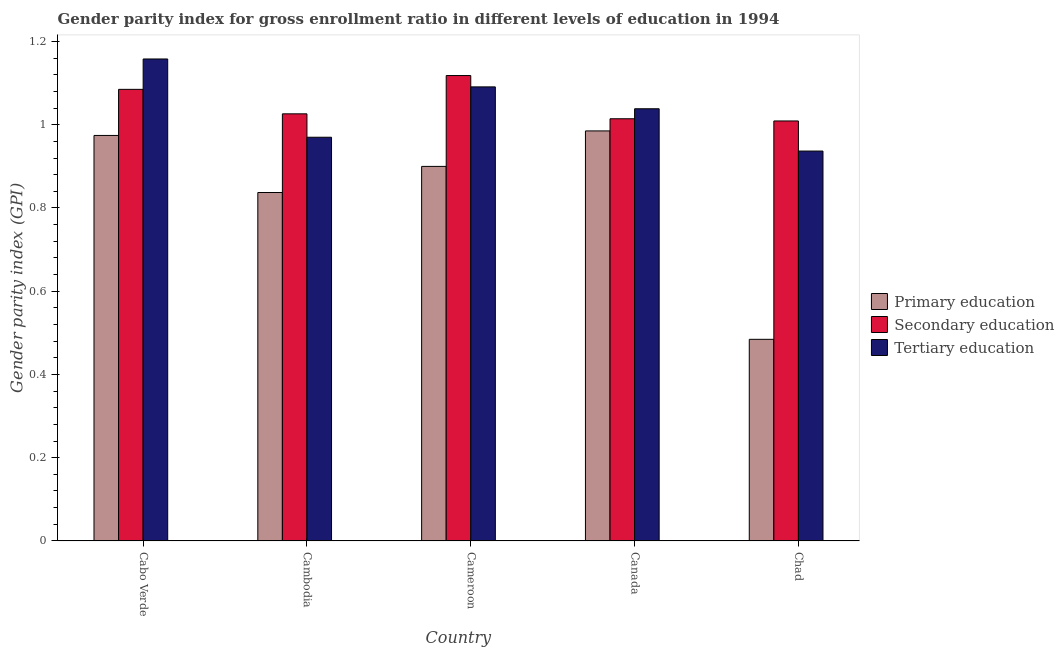How many bars are there on the 4th tick from the left?
Your answer should be compact. 3. How many bars are there on the 5th tick from the right?
Offer a very short reply. 3. What is the label of the 1st group of bars from the left?
Your answer should be compact. Cabo Verde. In how many cases, is the number of bars for a given country not equal to the number of legend labels?
Provide a succinct answer. 0. What is the gender parity index in primary education in Cameroon?
Your response must be concise. 0.9. Across all countries, what is the maximum gender parity index in secondary education?
Your answer should be very brief. 1.12. Across all countries, what is the minimum gender parity index in primary education?
Offer a terse response. 0.48. In which country was the gender parity index in tertiary education maximum?
Offer a terse response. Cabo Verde. In which country was the gender parity index in secondary education minimum?
Provide a succinct answer. Chad. What is the total gender parity index in primary education in the graph?
Offer a very short reply. 4.18. What is the difference between the gender parity index in secondary education in Cabo Verde and that in Canada?
Provide a short and direct response. 0.07. What is the difference between the gender parity index in primary education in Cambodia and the gender parity index in tertiary education in Canada?
Your answer should be very brief. -0.2. What is the average gender parity index in secondary education per country?
Offer a very short reply. 1.05. What is the difference between the gender parity index in tertiary education and gender parity index in secondary education in Cabo Verde?
Make the answer very short. 0.07. What is the ratio of the gender parity index in tertiary education in Cambodia to that in Chad?
Give a very brief answer. 1.04. Is the gender parity index in primary education in Cameroon less than that in Canada?
Provide a short and direct response. Yes. What is the difference between the highest and the second highest gender parity index in tertiary education?
Make the answer very short. 0.07. What is the difference between the highest and the lowest gender parity index in secondary education?
Give a very brief answer. 0.11. What does the 2nd bar from the right in Canada represents?
Offer a terse response. Secondary education. Is it the case that in every country, the sum of the gender parity index in primary education and gender parity index in secondary education is greater than the gender parity index in tertiary education?
Offer a very short reply. Yes. Does the graph contain any zero values?
Provide a succinct answer. No. Does the graph contain grids?
Offer a very short reply. No. Where does the legend appear in the graph?
Your answer should be compact. Center right. How many legend labels are there?
Make the answer very short. 3. What is the title of the graph?
Your response must be concise. Gender parity index for gross enrollment ratio in different levels of education in 1994. What is the label or title of the Y-axis?
Provide a succinct answer. Gender parity index (GPI). What is the Gender parity index (GPI) of Primary education in Cabo Verde?
Provide a succinct answer. 0.97. What is the Gender parity index (GPI) of Secondary education in Cabo Verde?
Give a very brief answer. 1.09. What is the Gender parity index (GPI) in Tertiary education in Cabo Verde?
Give a very brief answer. 1.16. What is the Gender parity index (GPI) of Primary education in Cambodia?
Make the answer very short. 0.84. What is the Gender parity index (GPI) in Secondary education in Cambodia?
Ensure brevity in your answer.  1.03. What is the Gender parity index (GPI) of Tertiary education in Cambodia?
Your answer should be compact. 0.97. What is the Gender parity index (GPI) in Primary education in Cameroon?
Offer a very short reply. 0.9. What is the Gender parity index (GPI) of Secondary education in Cameroon?
Offer a terse response. 1.12. What is the Gender parity index (GPI) of Tertiary education in Cameroon?
Provide a short and direct response. 1.09. What is the Gender parity index (GPI) in Primary education in Canada?
Your answer should be compact. 0.99. What is the Gender parity index (GPI) of Secondary education in Canada?
Your response must be concise. 1.01. What is the Gender parity index (GPI) of Tertiary education in Canada?
Offer a very short reply. 1.04. What is the Gender parity index (GPI) in Primary education in Chad?
Provide a succinct answer. 0.48. What is the Gender parity index (GPI) of Secondary education in Chad?
Provide a short and direct response. 1.01. What is the Gender parity index (GPI) in Tertiary education in Chad?
Your response must be concise. 0.94. Across all countries, what is the maximum Gender parity index (GPI) in Primary education?
Your answer should be compact. 0.99. Across all countries, what is the maximum Gender parity index (GPI) in Secondary education?
Keep it short and to the point. 1.12. Across all countries, what is the maximum Gender parity index (GPI) in Tertiary education?
Your response must be concise. 1.16. Across all countries, what is the minimum Gender parity index (GPI) of Primary education?
Your response must be concise. 0.48. Across all countries, what is the minimum Gender parity index (GPI) in Secondary education?
Your answer should be compact. 1.01. Across all countries, what is the minimum Gender parity index (GPI) of Tertiary education?
Give a very brief answer. 0.94. What is the total Gender parity index (GPI) of Primary education in the graph?
Provide a succinct answer. 4.18. What is the total Gender parity index (GPI) in Secondary education in the graph?
Your response must be concise. 5.25. What is the total Gender parity index (GPI) of Tertiary education in the graph?
Your answer should be compact. 5.19. What is the difference between the Gender parity index (GPI) of Primary education in Cabo Verde and that in Cambodia?
Keep it short and to the point. 0.14. What is the difference between the Gender parity index (GPI) in Secondary education in Cabo Verde and that in Cambodia?
Provide a succinct answer. 0.06. What is the difference between the Gender parity index (GPI) in Tertiary education in Cabo Verde and that in Cambodia?
Your answer should be very brief. 0.19. What is the difference between the Gender parity index (GPI) in Primary education in Cabo Verde and that in Cameroon?
Give a very brief answer. 0.07. What is the difference between the Gender parity index (GPI) in Secondary education in Cabo Verde and that in Cameroon?
Offer a very short reply. -0.03. What is the difference between the Gender parity index (GPI) of Tertiary education in Cabo Verde and that in Cameroon?
Ensure brevity in your answer.  0.07. What is the difference between the Gender parity index (GPI) of Primary education in Cabo Verde and that in Canada?
Offer a very short reply. -0.01. What is the difference between the Gender parity index (GPI) of Secondary education in Cabo Verde and that in Canada?
Provide a succinct answer. 0.07. What is the difference between the Gender parity index (GPI) of Tertiary education in Cabo Verde and that in Canada?
Provide a short and direct response. 0.12. What is the difference between the Gender parity index (GPI) of Primary education in Cabo Verde and that in Chad?
Keep it short and to the point. 0.49. What is the difference between the Gender parity index (GPI) of Secondary education in Cabo Verde and that in Chad?
Give a very brief answer. 0.08. What is the difference between the Gender parity index (GPI) in Tertiary education in Cabo Verde and that in Chad?
Ensure brevity in your answer.  0.22. What is the difference between the Gender parity index (GPI) of Primary education in Cambodia and that in Cameroon?
Make the answer very short. -0.06. What is the difference between the Gender parity index (GPI) in Secondary education in Cambodia and that in Cameroon?
Offer a terse response. -0.09. What is the difference between the Gender parity index (GPI) in Tertiary education in Cambodia and that in Cameroon?
Make the answer very short. -0.12. What is the difference between the Gender parity index (GPI) of Primary education in Cambodia and that in Canada?
Provide a short and direct response. -0.15. What is the difference between the Gender parity index (GPI) of Secondary education in Cambodia and that in Canada?
Ensure brevity in your answer.  0.01. What is the difference between the Gender parity index (GPI) in Tertiary education in Cambodia and that in Canada?
Ensure brevity in your answer.  -0.07. What is the difference between the Gender parity index (GPI) of Primary education in Cambodia and that in Chad?
Make the answer very short. 0.35. What is the difference between the Gender parity index (GPI) of Secondary education in Cambodia and that in Chad?
Keep it short and to the point. 0.02. What is the difference between the Gender parity index (GPI) of Tertiary education in Cambodia and that in Chad?
Provide a succinct answer. 0.03. What is the difference between the Gender parity index (GPI) of Primary education in Cameroon and that in Canada?
Give a very brief answer. -0.09. What is the difference between the Gender parity index (GPI) of Secondary education in Cameroon and that in Canada?
Provide a short and direct response. 0.1. What is the difference between the Gender parity index (GPI) in Tertiary education in Cameroon and that in Canada?
Your answer should be compact. 0.05. What is the difference between the Gender parity index (GPI) in Primary education in Cameroon and that in Chad?
Offer a terse response. 0.42. What is the difference between the Gender parity index (GPI) in Secondary education in Cameroon and that in Chad?
Keep it short and to the point. 0.11. What is the difference between the Gender parity index (GPI) in Tertiary education in Cameroon and that in Chad?
Your response must be concise. 0.15. What is the difference between the Gender parity index (GPI) of Primary education in Canada and that in Chad?
Your answer should be very brief. 0.5. What is the difference between the Gender parity index (GPI) of Secondary education in Canada and that in Chad?
Give a very brief answer. 0.01. What is the difference between the Gender parity index (GPI) in Tertiary education in Canada and that in Chad?
Provide a short and direct response. 0.1. What is the difference between the Gender parity index (GPI) of Primary education in Cabo Verde and the Gender parity index (GPI) of Secondary education in Cambodia?
Offer a very short reply. -0.05. What is the difference between the Gender parity index (GPI) of Primary education in Cabo Verde and the Gender parity index (GPI) of Tertiary education in Cambodia?
Provide a short and direct response. 0. What is the difference between the Gender parity index (GPI) in Secondary education in Cabo Verde and the Gender parity index (GPI) in Tertiary education in Cambodia?
Your answer should be compact. 0.12. What is the difference between the Gender parity index (GPI) in Primary education in Cabo Verde and the Gender parity index (GPI) in Secondary education in Cameroon?
Your response must be concise. -0.14. What is the difference between the Gender parity index (GPI) of Primary education in Cabo Verde and the Gender parity index (GPI) of Tertiary education in Cameroon?
Provide a short and direct response. -0.12. What is the difference between the Gender parity index (GPI) in Secondary education in Cabo Verde and the Gender parity index (GPI) in Tertiary education in Cameroon?
Offer a terse response. -0.01. What is the difference between the Gender parity index (GPI) of Primary education in Cabo Verde and the Gender parity index (GPI) of Secondary education in Canada?
Offer a very short reply. -0.04. What is the difference between the Gender parity index (GPI) of Primary education in Cabo Verde and the Gender parity index (GPI) of Tertiary education in Canada?
Your answer should be compact. -0.06. What is the difference between the Gender parity index (GPI) of Secondary education in Cabo Verde and the Gender parity index (GPI) of Tertiary education in Canada?
Give a very brief answer. 0.05. What is the difference between the Gender parity index (GPI) in Primary education in Cabo Verde and the Gender parity index (GPI) in Secondary education in Chad?
Your response must be concise. -0.03. What is the difference between the Gender parity index (GPI) in Primary education in Cabo Verde and the Gender parity index (GPI) in Tertiary education in Chad?
Provide a succinct answer. 0.04. What is the difference between the Gender parity index (GPI) in Secondary education in Cabo Verde and the Gender parity index (GPI) in Tertiary education in Chad?
Offer a terse response. 0.15. What is the difference between the Gender parity index (GPI) in Primary education in Cambodia and the Gender parity index (GPI) in Secondary education in Cameroon?
Ensure brevity in your answer.  -0.28. What is the difference between the Gender parity index (GPI) in Primary education in Cambodia and the Gender parity index (GPI) in Tertiary education in Cameroon?
Make the answer very short. -0.25. What is the difference between the Gender parity index (GPI) in Secondary education in Cambodia and the Gender parity index (GPI) in Tertiary education in Cameroon?
Keep it short and to the point. -0.06. What is the difference between the Gender parity index (GPI) in Primary education in Cambodia and the Gender parity index (GPI) in Secondary education in Canada?
Your answer should be very brief. -0.18. What is the difference between the Gender parity index (GPI) of Primary education in Cambodia and the Gender parity index (GPI) of Tertiary education in Canada?
Offer a terse response. -0.2. What is the difference between the Gender parity index (GPI) of Secondary education in Cambodia and the Gender parity index (GPI) of Tertiary education in Canada?
Provide a short and direct response. -0.01. What is the difference between the Gender parity index (GPI) of Primary education in Cambodia and the Gender parity index (GPI) of Secondary education in Chad?
Your answer should be compact. -0.17. What is the difference between the Gender parity index (GPI) of Primary education in Cambodia and the Gender parity index (GPI) of Tertiary education in Chad?
Provide a short and direct response. -0.1. What is the difference between the Gender parity index (GPI) of Secondary education in Cambodia and the Gender parity index (GPI) of Tertiary education in Chad?
Provide a succinct answer. 0.09. What is the difference between the Gender parity index (GPI) of Primary education in Cameroon and the Gender parity index (GPI) of Secondary education in Canada?
Your answer should be very brief. -0.11. What is the difference between the Gender parity index (GPI) of Primary education in Cameroon and the Gender parity index (GPI) of Tertiary education in Canada?
Keep it short and to the point. -0.14. What is the difference between the Gender parity index (GPI) of Secondary education in Cameroon and the Gender parity index (GPI) of Tertiary education in Canada?
Your response must be concise. 0.08. What is the difference between the Gender parity index (GPI) of Primary education in Cameroon and the Gender parity index (GPI) of Secondary education in Chad?
Your answer should be very brief. -0.11. What is the difference between the Gender parity index (GPI) of Primary education in Cameroon and the Gender parity index (GPI) of Tertiary education in Chad?
Offer a terse response. -0.04. What is the difference between the Gender parity index (GPI) in Secondary education in Cameroon and the Gender parity index (GPI) in Tertiary education in Chad?
Keep it short and to the point. 0.18. What is the difference between the Gender parity index (GPI) in Primary education in Canada and the Gender parity index (GPI) in Secondary education in Chad?
Give a very brief answer. -0.02. What is the difference between the Gender parity index (GPI) in Primary education in Canada and the Gender parity index (GPI) in Tertiary education in Chad?
Your response must be concise. 0.05. What is the difference between the Gender parity index (GPI) of Secondary education in Canada and the Gender parity index (GPI) of Tertiary education in Chad?
Offer a very short reply. 0.08. What is the average Gender parity index (GPI) in Primary education per country?
Ensure brevity in your answer.  0.84. What is the average Gender parity index (GPI) of Secondary education per country?
Provide a short and direct response. 1.05. What is the average Gender parity index (GPI) in Tertiary education per country?
Ensure brevity in your answer.  1.04. What is the difference between the Gender parity index (GPI) in Primary education and Gender parity index (GPI) in Secondary education in Cabo Verde?
Provide a short and direct response. -0.11. What is the difference between the Gender parity index (GPI) in Primary education and Gender parity index (GPI) in Tertiary education in Cabo Verde?
Make the answer very short. -0.18. What is the difference between the Gender parity index (GPI) of Secondary education and Gender parity index (GPI) of Tertiary education in Cabo Verde?
Offer a terse response. -0.07. What is the difference between the Gender parity index (GPI) of Primary education and Gender parity index (GPI) of Secondary education in Cambodia?
Offer a very short reply. -0.19. What is the difference between the Gender parity index (GPI) of Primary education and Gender parity index (GPI) of Tertiary education in Cambodia?
Make the answer very short. -0.13. What is the difference between the Gender parity index (GPI) of Secondary education and Gender parity index (GPI) of Tertiary education in Cambodia?
Your answer should be very brief. 0.06. What is the difference between the Gender parity index (GPI) in Primary education and Gender parity index (GPI) in Secondary education in Cameroon?
Your answer should be very brief. -0.22. What is the difference between the Gender parity index (GPI) of Primary education and Gender parity index (GPI) of Tertiary education in Cameroon?
Offer a very short reply. -0.19. What is the difference between the Gender parity index (GPI) of Secondary education and Gender parity index (GPI) of Tertiary education in Cameroon?
Provide a succinct answer. 0.03. What is the difference between the Gender parity index (GPI) of Primary education and Gender parity index (GPI) of Secondary education in Canada?
Provide a short and direct response. -0.03. What is the difference between the Gender parity index (GPI) of Primary education and Gender parity index (GPI) of Tertiary education in Canada?
Provide a succinct answer. -0.05. What is the difference between the Gender parity index (GPI) of Secondary education and Gender parity index (GPI) of Tertiary education in Canada?
Provide a succinct answer. -0.02. What is the difference between the Gender parity index (GPI) in Primary education and Gender parity index (GPI) in Secondary education in Chad?
Provide a succinct answer. -0.52. What is the difference between the Gender parity index (GPI) of Primary education and Gender parity index (GPI) of Tertiary education in Chad?
Provide a short and direct response. -0.45. What is the difference between the Gender parity index (GPI) of Secondary education and Gender parity index (GPI) of Tertiary education in Chad?
Provide a short and direct response. 0.07. What is the ratio of the Gender parity index (GPI) in Primary education in Cabo Verde to that in Cambodia?
Your response must be concise. 1.16. What is the ratio of the Gender parity index (GPI) in Secondary education in Cabo Verde to that in Cambodia?
Offer a very short reply. 1.06. What is the ratio of the Gender parity index (GPI) in Tertiary education in Cabo Verde to that in Cambodia?
Your answer should be very brief. 1.19. What is the ratio of the Gender parity index (GPI) in Primary education in Cabo Verde to that in Cameroon?
Keep it short and to the point. 1.08. What is the ratio of the Gender parity index (GPI) of Secondary education in Cabo Verde to that in Cameroon?
Provide a succinct answer. 0.97. What is the ratio of the Gender parity index (GPI) of Tertiary education in Cabo Verde to that in Cameroon?
Offer a terse response. 1.06. What is the ratio of the Gender parity index (GPI) of Primary education in Cabo Verde to that in Canada?
Provide a succinct answer. 0.99. What is the ratio of the Gender parity index (GPI) in Secondary education in Cabo Verde to that in Canada?
Keep it short and to the point. 1.07. What is the ratio of the Gender parity index (GPI) in Tertiary education in Cabo Verde to that in Canada?
Ensure brevity in your answer.  1.12. What is the ratio of the Gender parity index (GPI) of Primary education in Cabo Verde to that in Chad?
Keep it short and to the point. 2.01. What is the ratio of the Gender parity index (GPI) in Secondary education in Cabo Verde to that in Chad?
Your answer should be very brief. 1.08. What is the ratio of the Gender parity index (GPI) in Tertiary education in Cabo Verde to that in Chad?
Your answer should be compact. 1.24. What is the ratio of the Gender parity index (GPI) in Primary education in Cambodia to that in Cameroon?
Offer a terse response. 0.93. What is the ratio of the Gender parity index (GPI) of Secondary education in Cambodia to that in Cameroon?
Your answer should be compact. 0.92. What is the ratio of the Gender parity index (GPI) in Tertiary education in Cambodia to that in Cameroon?
Your answer should be compact. 0.89. What is the ratio of the Gender parity index (GPI) in Primary education in Cambodia to that in Canada?
Provide a short and direct response. 0.85. What is the ratio of the Gender parity index (GPI) of Secondary education in Cambodia to that in Canada?
Offer a terse response. 1.01. What is the ratio of the Gender parity index (GPI) in Tertiary education in Cambodia to that in Canada?
Your response must be concise. 0.93. What is the ratio of the Gender parity index (GPI) of Primary education in Cambodia to that in Chad?
Your answer should be very brief. 1.73. What is the ratio of the Gender parity index (GPI) in Secondary education in Cambodia to that in Chad?
Offer a terse response. 1.02. What is the ratio of the Gender parity index (GPI) of Tertiary education in Cambodia to that in Chad?
Offer a very short reply. 1.04. What is the ratio of the Gender parity index (GPI) in Primary education in Cameroon to that in Canada?
Your answer should be very brief. 0.91. What is the ratio of the Gender parity index (GPI) in Secondary education in Cameroon to that in Canada?
Offer a very short reply. 1.1. What is the ratio of the Gender parity index (GPI) in Tertiary education in Cameroon to that in Canada?
Your answer should be compact. 1.05. What is the ratio of the Gender parity index (GPI) of Primary education in Cameroon to that in Chad?
Give a very brief answer. 1.86. What is the ratio of the Gender parity index (GPI) in Secondary education in Cameroon to that in Chad?
Provide a succinct answer. 1.11. What is the ratio of the Gender parity index (GPI) of Tertiary education in Cameroon to that in Chad?
Provide a succinct answer. 1.16. What is the ratio of the Gender parity index (GPI) of Primary education in Canada to that in Chad?
Keep it short and to the point. 2.03. What is the ratio of the Gender parity index (GPI) in Tertiary education in Canada to that in Chad?
Your answer should be very brief. 1.11. What is the difference between the highest and the second highest Gender parity index (GPI) of Primary education?
Offer a very short reply. 0.01. What is the difference between the highest and the second highest Gender parity index (GPI) of Secondary education?
Provide a succinct answer. 0.03. What is the difference between the highest and the second highest Gender parity index (GPI) of Tertiary education?
Your response must be concise. 0.07. What is the difference between the highest and the lowest Gender parity index (GPI) of Primary education?
Offer a very short reply. 0.5. What is the difference between the highest and the lowest Gender parity index (GPI) of Secondary education?
Provide a short and direct response. 0.11. What is the difference between the highest and the lowest Gender parity index (GPI) of Tertiary education?
Keep it short and to the point. 0.22. 